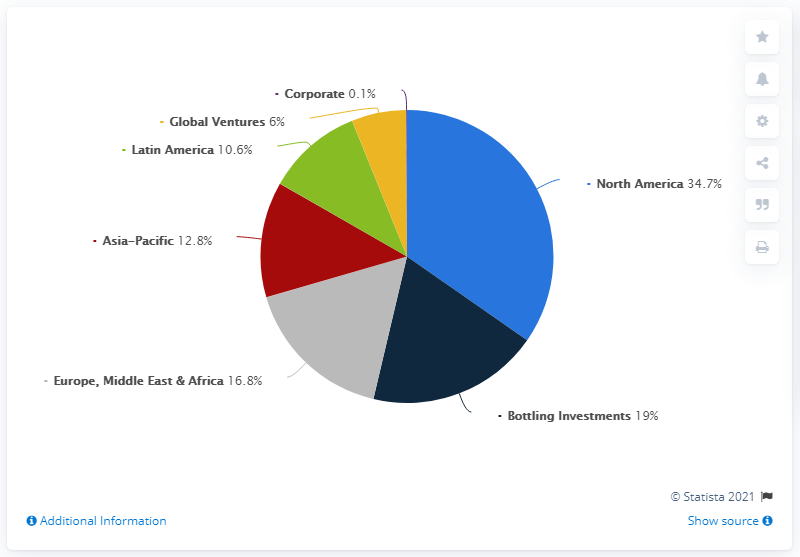Specify some key components in this picture. The region that contributes the largest revenue is North America. In North and Latin America, the region contributed 45.3% of the total revenue of the company in the last fiscal year. 